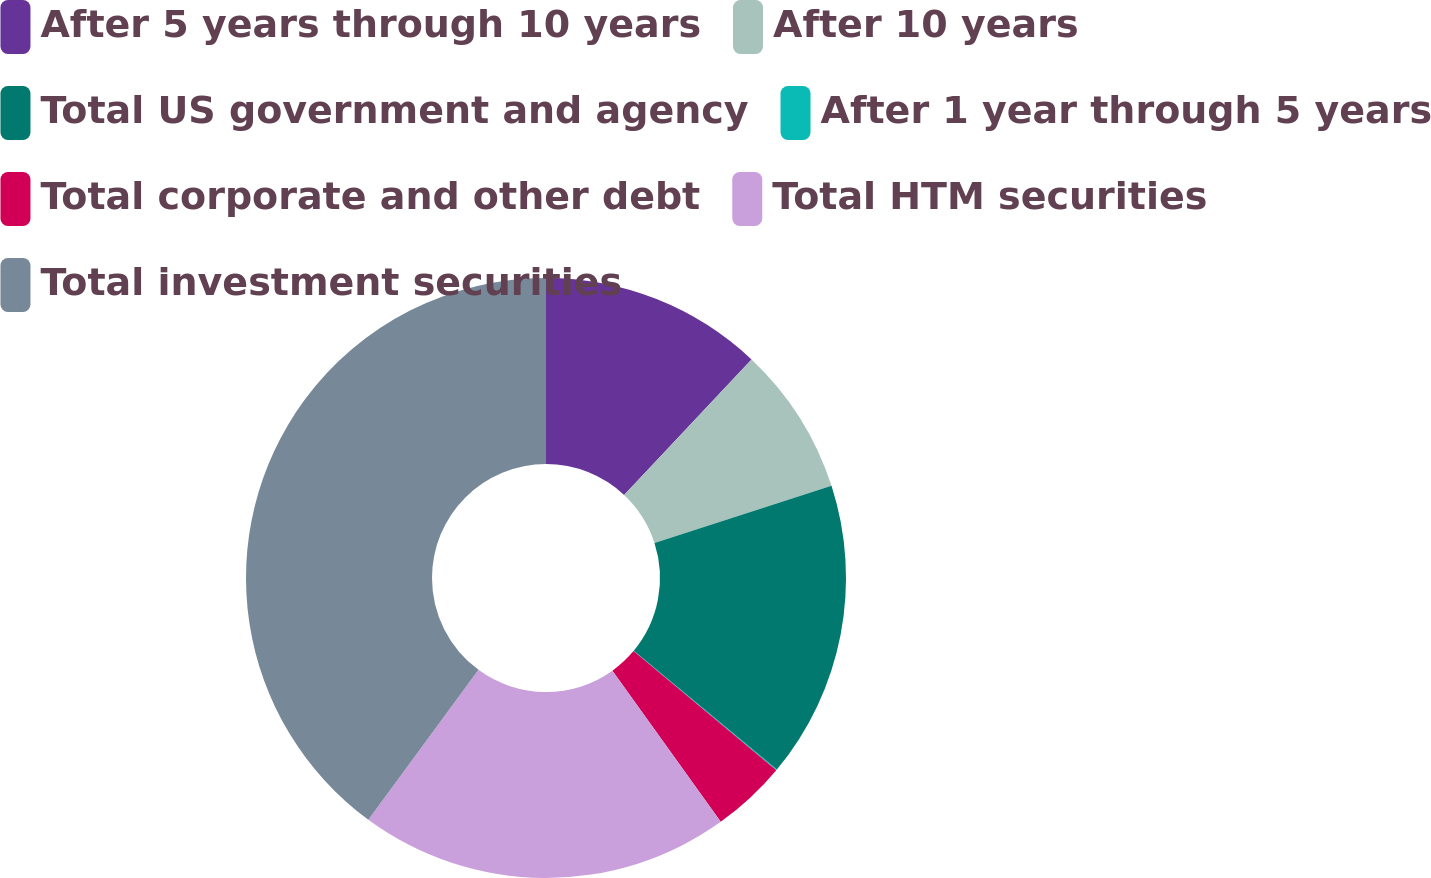<chart> <loc_0><loc_0><loc_500><loc_500><pie_chart><fcel>After 5 years through 10 years<fcel>After 10 years<fcel>Total US government and agency<fcel>After 1 year through 5 years<fcel>Total corporate and other debt<fcel>Total HTM securities<fcel>Total investment securities<nl><fcel>12.01%<fcel>8.02%<fcel>15.99%<fcel>0.05%<fcel>4.03%<fcel>19.98%<fcel>39.91%<nl></chart> 